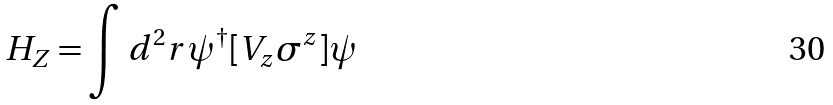Convert formula to latex. <formula><loc_0><loc_0><loc_500><loc_500>H _ { Z } = \int d ^ { 2 } { r } \psi ^ { \dagger } [ V _ { z } \sigma ^ { z } ] \psi</formula> 